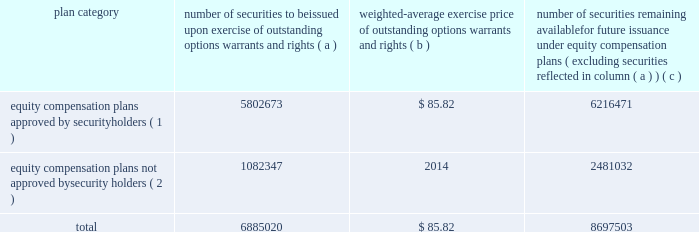Item 12 .
Security ownership of certain beneficial owners and management and related stockholder matters .
The information required by item 12 is included under the heading 201csecurity ownership of management and certain beneficial owners 201d in the 2017 proxy statement , and that information is incorporated by reference in this form 10-k .
Equity compensation plan information the table provides information about our equity compensation plans that authorize the issuance of shares of lockheed martin common stock to employees and directors .
The information is provided as of december 31 , 2016 .
Plan category number of securities to be issued exercise of outstanding options , warrants and rights weighted-average exercise price of outstanding options , warrants and rights number of securities remaining available for future issuance under equity compensation ( excluding securities reflected in column ( a ) ) equity compensation plans approved by security holders ( 1 ) 5802673 $ 85.82 6216471 equity compensation plans not approved by security holders ( 2 ) 1082347 2014 2481032 .
( 1 ) column ( a ) includes , as of december 31 , 2016 : 1747151 shares that have been granted as restricted stock units ( rsus ) , 936308 shares that could be earned pursuant to grants of performance stock units ( psus ) ( assuming the maximum number of psus are earned and payable at the end of the three-year performance period ) and 2967046 shares granted as options under the lockheed martin corporation 2011 incentive performance award plan ( 2011 ipa plan ) or predecessor plans prior to january 1 , 2013 and 23346 shares granted as options and 128822 stock units payable in stock or cash under the lockheed martin corporation 2009 directors equity plan ( directors equity plan ) or predecessor plans for members ( or former members ) of the board of directors .
Column ( c ) includes , as of december 31 , 2016 , 5751655 shares available for future issuance under the 2011 ipa plan as options , stock appreciation rights ( sars ) , restricted stock awards ( rsas ) , rsus or psus and 464816 shares available for future issuance under the directors equity plan as stock options and stock units .
Of the 5751655 shares available for grant under the 2011 ipa plan on december 31 , 2016 , 516653 and 236654 shares are issuable pursuant to grants made on january 26 , 2017 , of rsus and psus ( assuming the maximum number of psus are earned and payable at the end of the three-year performance period ) , respectively .
The weighted average price does not take into account shares issued pursuant to rsus or psus .
( 2 ) the shares represent annual incentive bonuses and long-term incentive performance ( ltip ) payments earned and voluntarily deferred by employees .
The deferred amounts are payable under the deferred management incentive compensation plan ( dmicp ) .
Deferred amounts are credited as phantom stock units at the closing price of our stock on the date the deferral is effective .
Amounts equal to our dividend are credited as stock units at the time we pay a dividend .
Following termination of employment , a number of shares of stock equal to the number of stock units credited to the employee 2019s dmicp account are distributed to the employee .
There is no discount or value transfer on the stock distributed .
Distributions may be made from newly issued shares or shares purchased on the open market .
Historically , all distributions have come from shares held in a separate trust and , therefore , do not further dilute our common shares outstanding .
As a result , these shares also were not considered in calculating the total weighted average exercise price in the table .
Because the dmicp shares are outstanding , they should be included in the denominator ( and not the numerator ) of a dilution calculation .
Item 13 .
Certain relationships and related transactions and director independence .
The information required by this item 13 is included under the captions 201ccorporate governance 2013 related person transaction policy , 201d 201ccorporate governance 2013 certain relationships and related person transactions of directors , executive officers , and 5 percent stockholders , 201d and 201ccorporate governance 2013 director independence 201d in the 2017 proxy statement , and that information is incorporated by reference in this form 10-k .
Item 14 .
Principal accountant fees and services .
The information required by this item 14 is included under the caption 201cproposal 2 2013 ratification of appointment of independent auditors 201d in the 2017 proxy statement , and that information is incorporated by reference in this form 10-k. .
What portion of the total number of issues securities is approved by the security holders? 
Computations: (5802673 / 6885020)
Answer: 0.8428. 